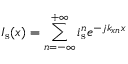Convert formula to latex. <formula><loc_0><loc_0><loc_500><loc_500>I _ { s } ( x ) = \sum _ { n = - \infty } ^ { + \infty } i _ { s } ^ { n } e ^ { - j k _ { x n } x }</formula> 